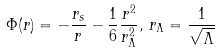Convert formula to latex. <formula><loc_0><loc_0><loc_500><loc_500>\Phi ( r ) = - \frac { r _ { s } } { r } - \frac { 1 } { 6 } \frac { r ^ { 2 } } { r _ { \Lambda } ^ { 2 } } , \, r _ { \Lambda } = \frac { 1 } { \sqrt { \Lambda } }</formula> 